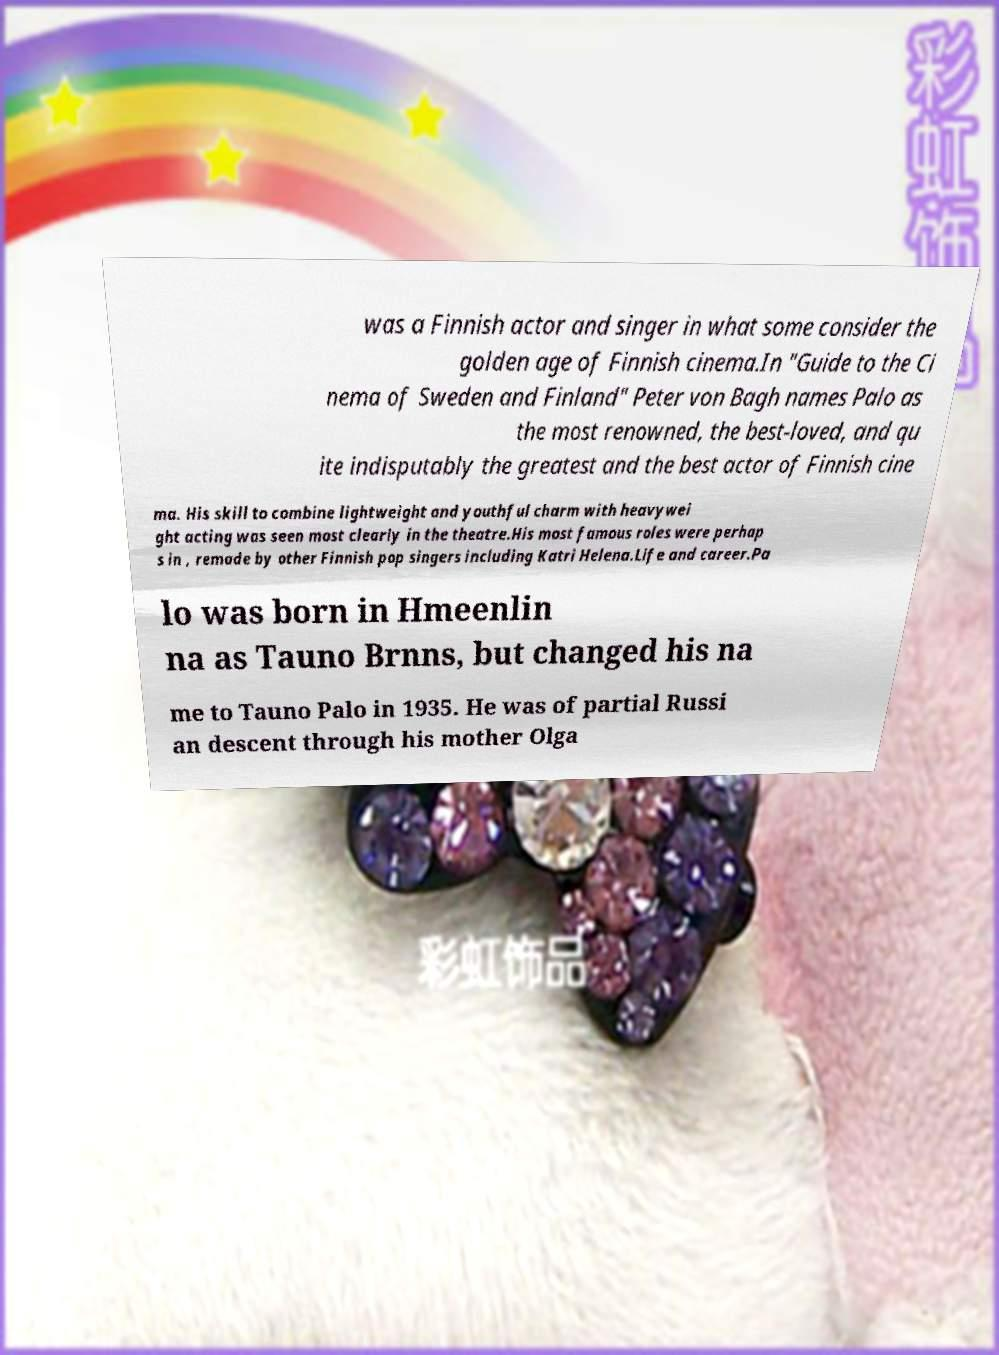Could you assist in decoding the text presented in this image and type it out clearly? was a Finnish actor and singer in what some consider the golden age of Finnish cinema.In "Guide to the Ci nema of Sweden and Finland" Peter von Bagh names Palo as the most renowned, the best-loved, and qu ite indisputably the greatest and the best actor of Finnish cine ma. His skill to combine lightweight and youthful charm with heavywei ght acting was seen most clearly in the theatre.His most famous roles were perhap s in , remade by other Finnish pop singers including Katri Helena.Life and career.Pa lo was born in Hmeenlin na as Tauno Brnns, but changed his na me to Tauno Palo in 1935. He was of partial Russi an descent through his mother Olga 